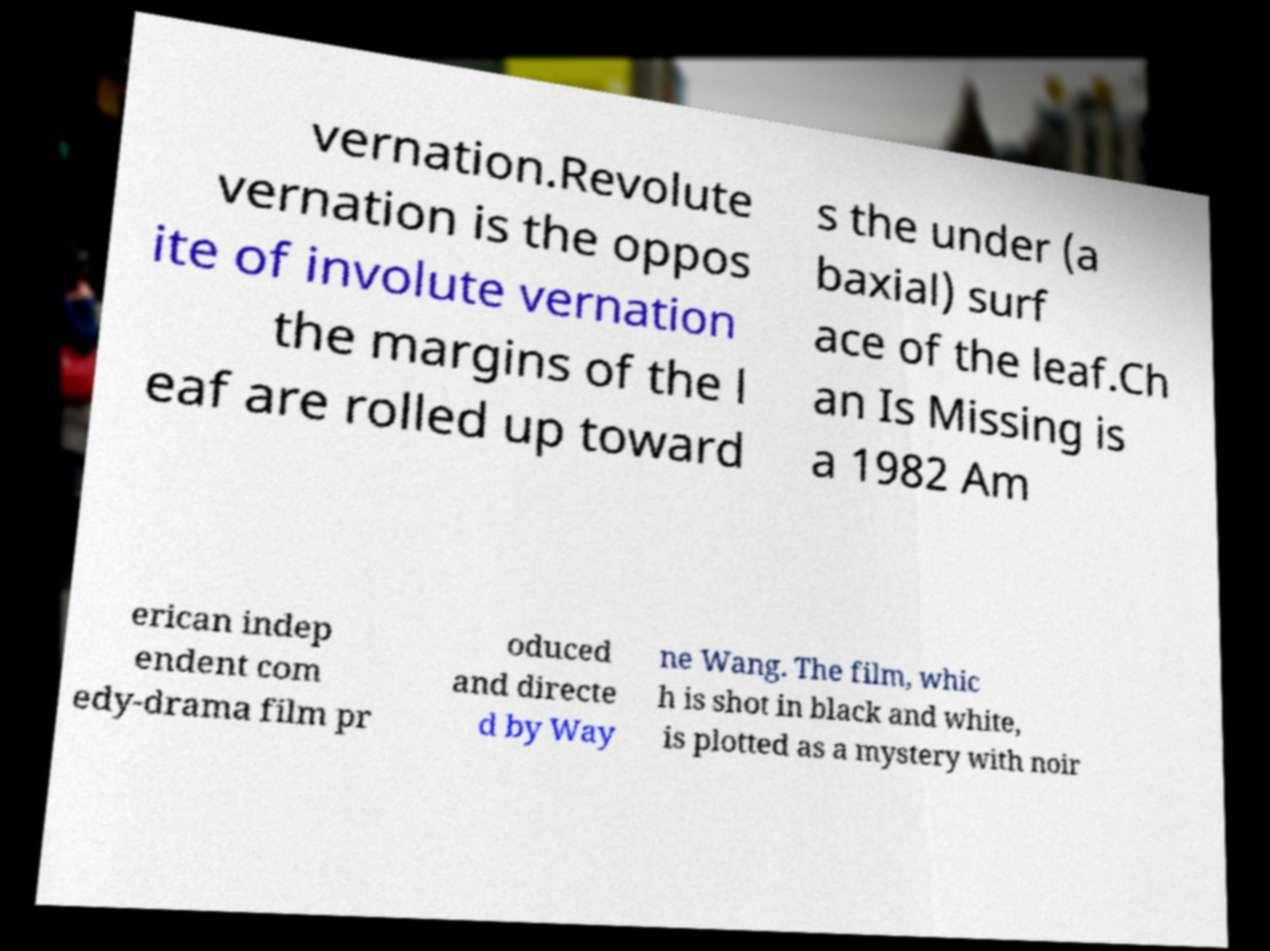Please read and relay the text visible in this image. What does it say? vernation.Revolute vernation is the oppos ite of involute vernation the margins of the l eaf are rolled up toward s the under (a baxial) surf ace of the leaf.Ch an Is Missing is a 1982 Am erican indep endent com edy-drama film pr oduced and directe d by Way ne Wang. The film, whic h is shot in black and white, is plotted as a mystery with noir 